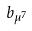Convert formula to latex. <formula><loc_0><loc_0><loc_500><loc_500>b _ { \mu ^ { 7 } }</formula> 